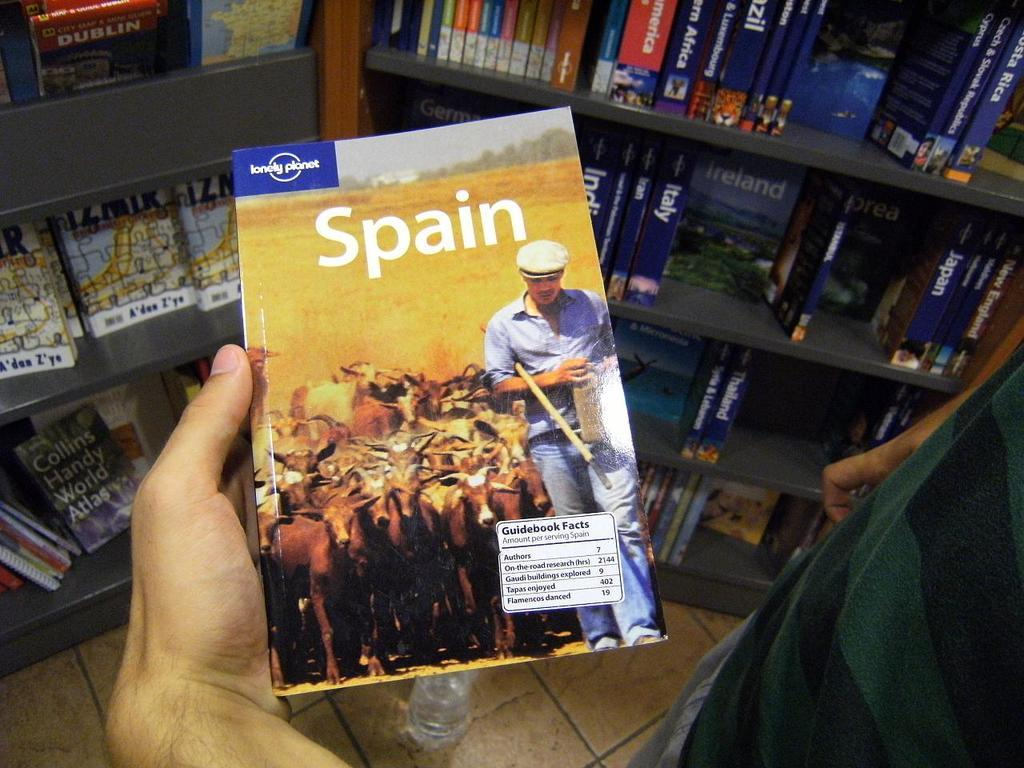<image>
Give a short and clear explanation of the subsequent image. a book that someone is holding that is called 'spain' 